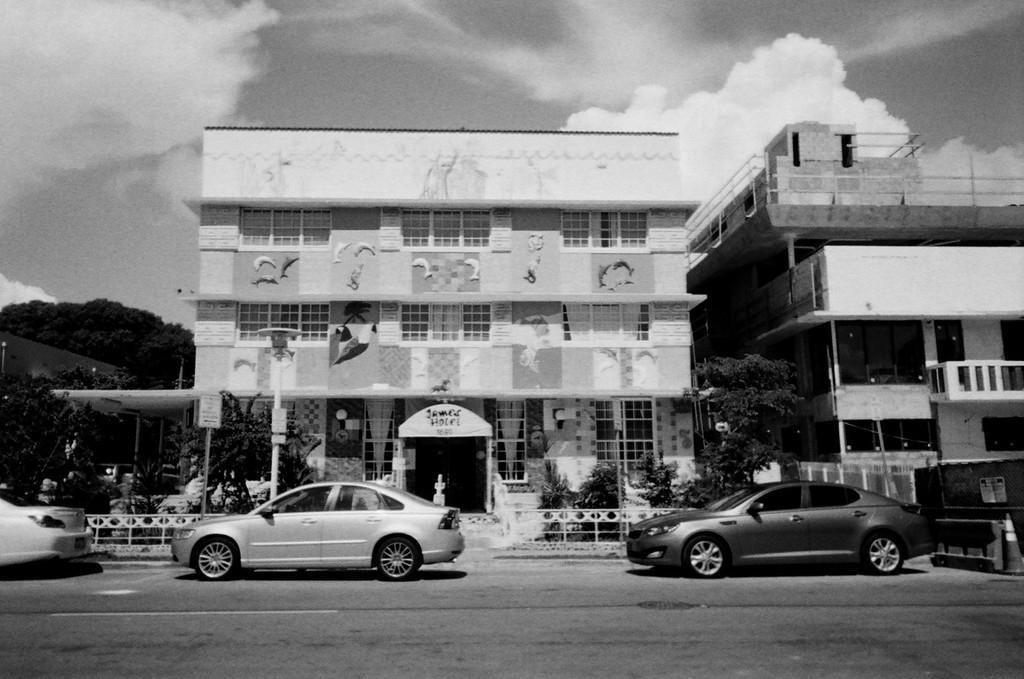In one or two sentences, can you explain what this image depicts? In the picture I can see buildings, trees, vehicles on the road, fence, poles and some other objects. In the background I can see the sky. 